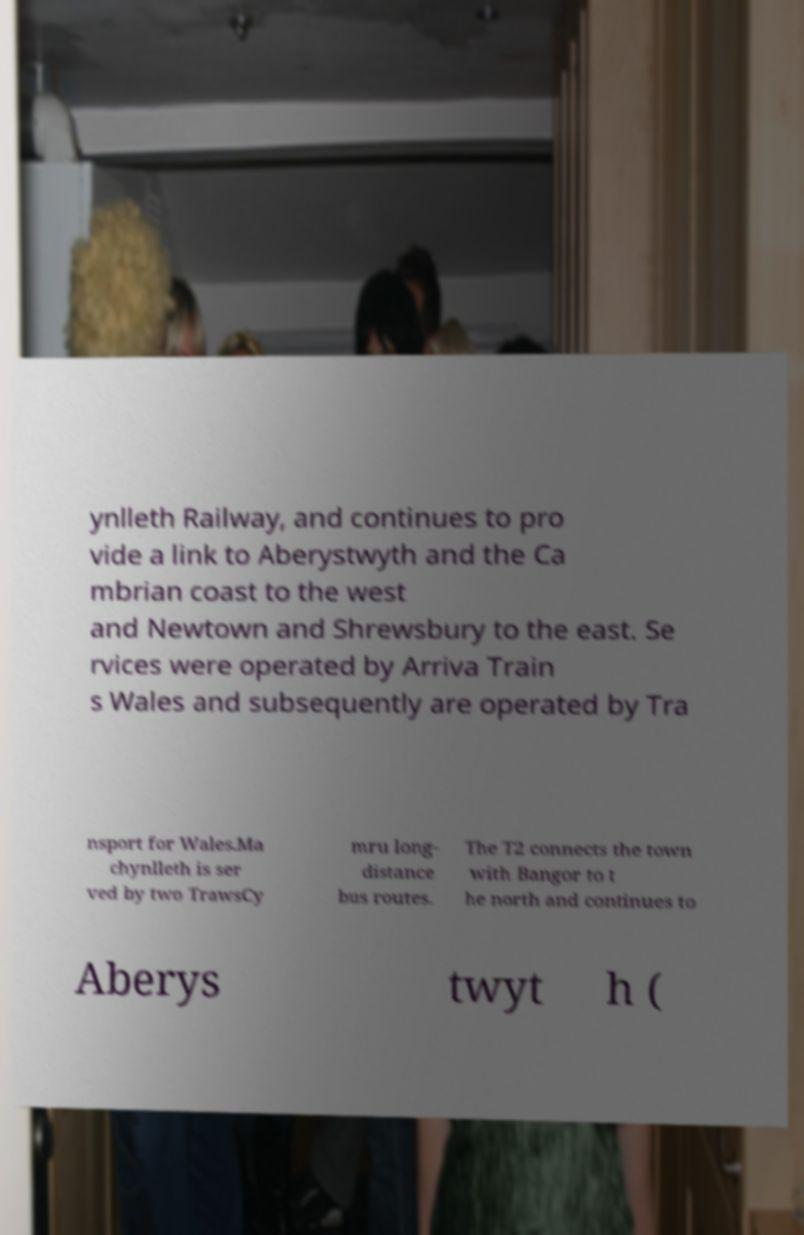Can you accurately transcribe the text from the provided image for me? ynlleth Railway, and continues to pro vide a link to Aberystwyth and the Ca mbrian coast to the west and Newtown and Shrewsbury to the east. Se rvices were operated by Arriva Train s Wales and subsequently are operated by Tra nsport for Wales.Ma chynlleth is ser ved by two TrawsCy mru long- distance bus routes. The T2 connects the town with Bangor to t he north and continues to Aberys twyt h ( 